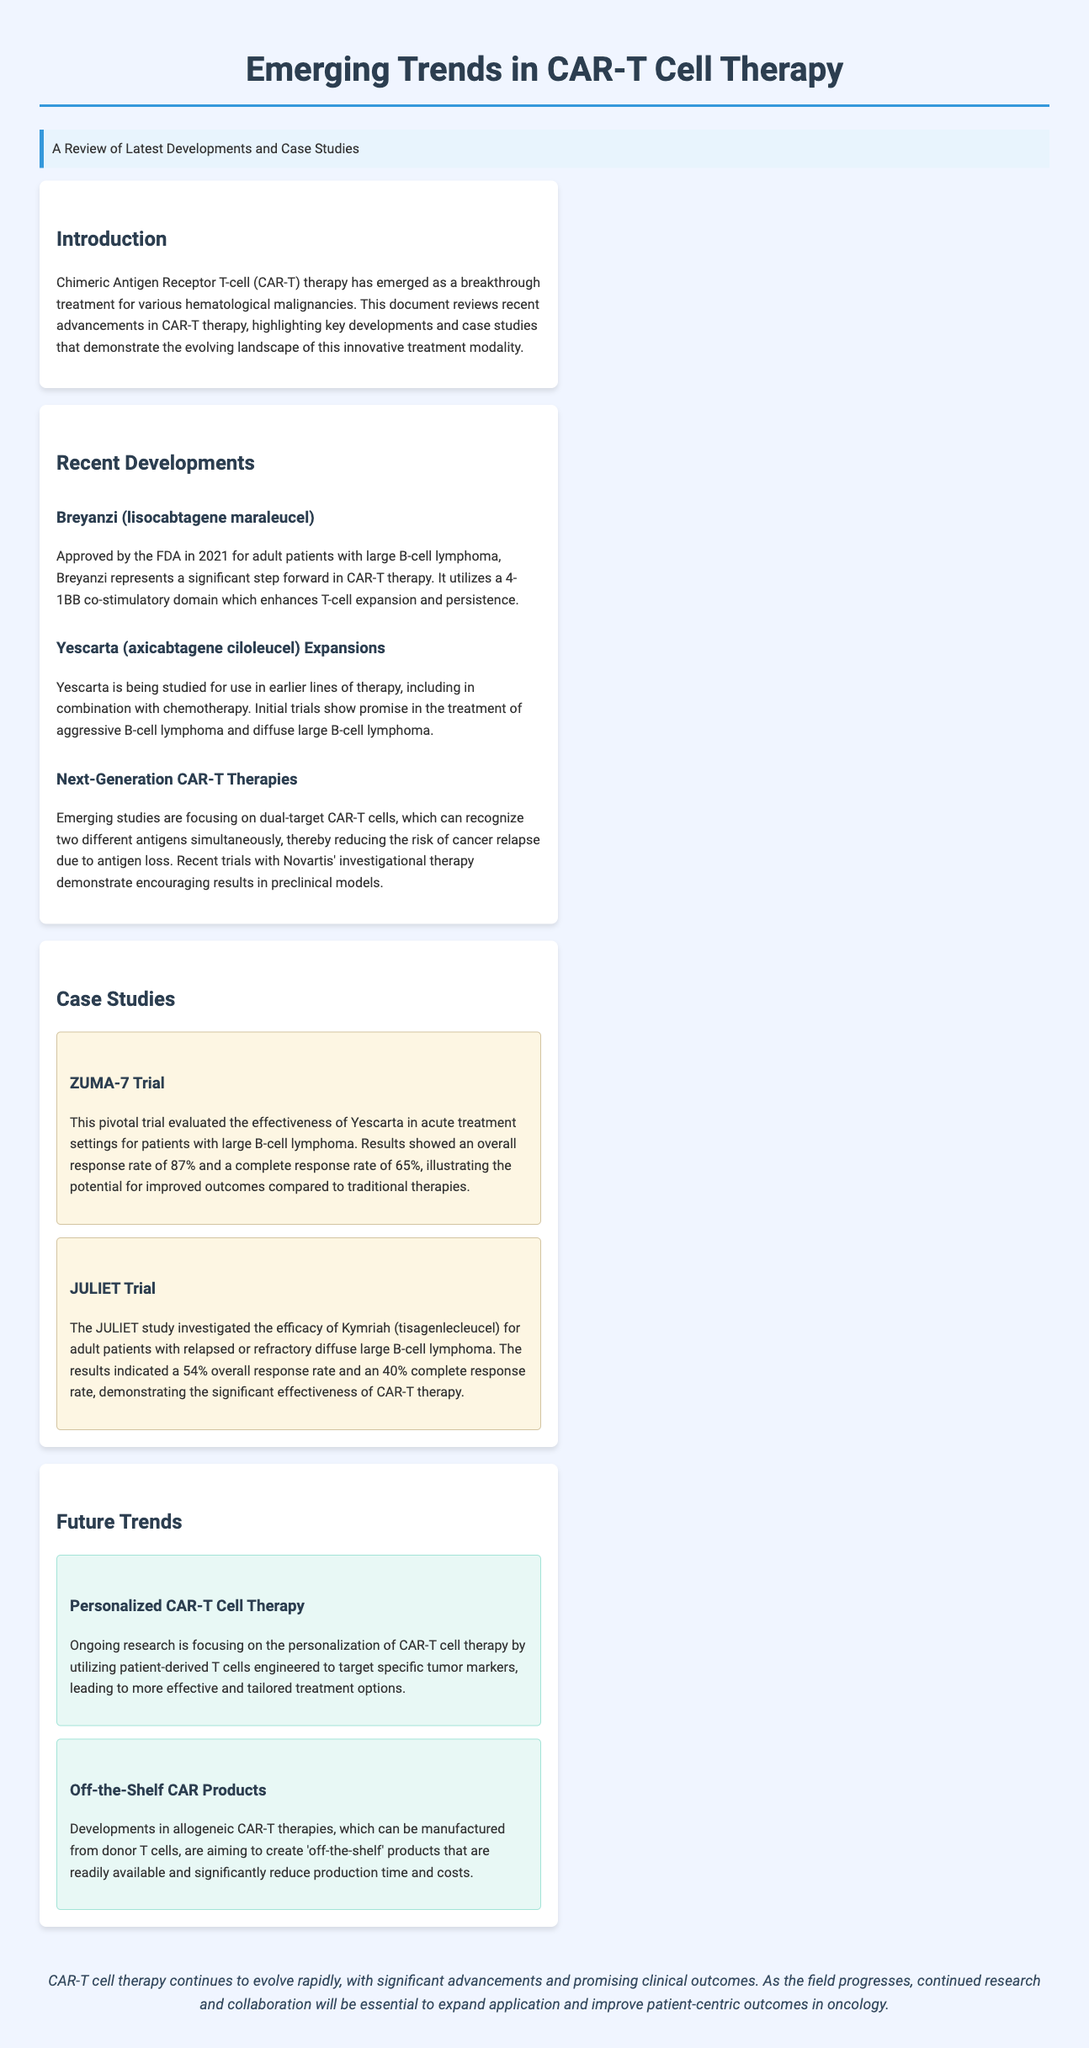what therapy does CAR-T cells target? The document specifies that CAR-T therapy is a treatment for various hematological malignancies.
Answer: hematological malignancies what is the overall response rate in the ZUMA-7 trial? The document states that the ZUMA-7 trial showed an overall response rate of 87%.
Answer: 87% which CAR-T product was approved by the FDA in 2021? The document mentions that Breyanzi (lisocabtagene maraleucel) was approved by the FDA in 2021.
Answer: Breyanzi (lisocabtagene maraleucel) what was the complete response rate in the JULIET trial? According to the document, the JULIET trial showed a complete response rate of 40%.
Answer: 40% what is one future trend in CAR-T cell therapy? The document lists the personalization of CAR-T cell therapy as a future trend.
Answer: Personalized CAR-T Cell Therapy what co-stimulatory domain is used in Breyanzi? The document specifies that Breyanzi utilizes a 4-1BB co-stimulatory domain.
Answer: 4-1BB how does the document categorize the ZUMA-7 and JULIET trials? The document categorizes these trials as case studies.
Answer: case studies what type of CAR-T therapies are referred to as 'off-the-shelf'? The document discusses allogeneic CAR-T therapies as 'off-the-shelf' products.
Answer: allogeneic CAR-T therapies 